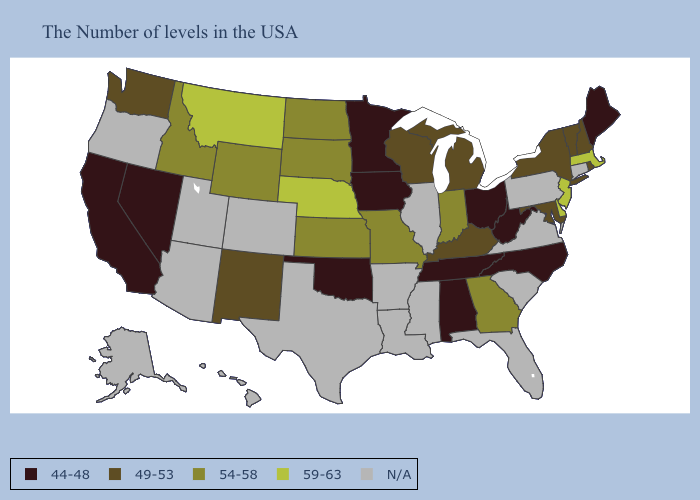Among the states that border Utah , which have the highest value?
Keep it brief. Wyoming, Idaho. What is the highest value in the South ?
Concise answer only. 59-63. Among the states that border Missouri , which have the highest value?
Concise answer only. Nebraska. Name the states that have a value in the range 49-53?
Quick response, please. Rhode Island, New Hampshire, Vermont, New York, Maryland, Michigan, Kentucky, Wisconsin, New Mexico, Washington. Does the map have missing data?
Write a very short answer. Yes. Name the states that have a value in the range 49-53?
Short answer required. Rhode Island, New Hampshire, Vermont, New York, Maryland, Michigan, Kentucky, Wisconsin, New Mexico, Washington. Name the states that have a value in the range 59-63?
Short answer required. Massachusetts, New Jersey, Delaware, Nebraska, Montana. What is the lowest value in the Northeast?
Answer briefly. 44-48. Does Kentucky have the highest value in the USA?
Be succinct. No. What is the value of Utah?
Short answer required. N/A. Among the states that border Tennessee , which have the highest value?
Answer briefly. Georgia, Missouri. What is the value of Colorado?
Answer briefly. N/A. Does the map have missing data?
Short answer required. Yes. What is the lowest value in the Northeast?
Give a very brief answer. 44-48. Name the states that have a value in the range N/A?
Short answer required. Connecticut, Pennsylvania, Virginia, South Carolina, Florida, Illinois, Mississippi, Louisiana, Arkansas, Texas, Colorado, Utah, Arizona, Oregon, Alaska, Hawaii. 